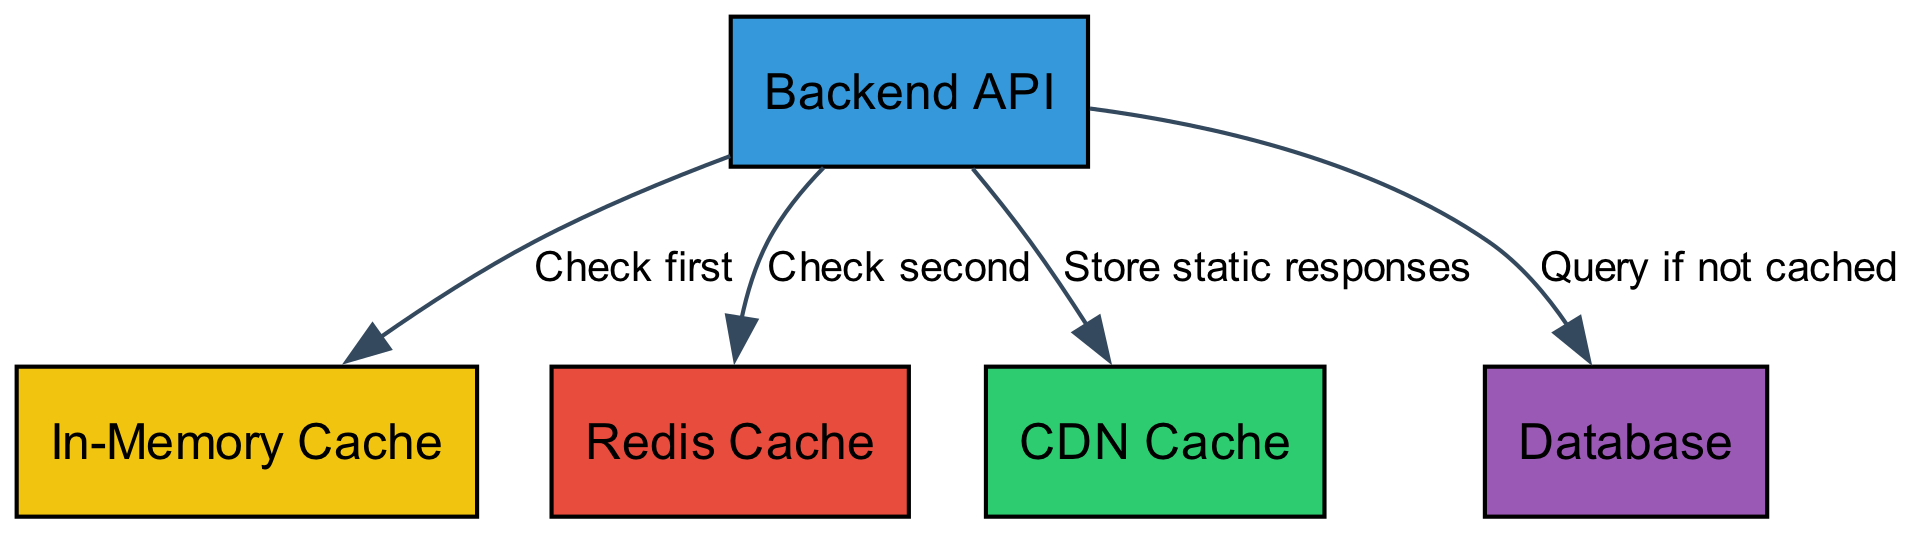What are the different caching layers shown in the diagram? The diagram includes five nodes: Backend API, In-Memory Cache, Redis Cache, CDN Cache, and Database. These represent the various layers of caching.
Answer: Backend API, In-Memory Cache, Redis Cache, CDN Cache, Database How many edges are there in the diagram? The total number of edges is determined by counting the connections between the nodes shown in the diagram: there are four edges connecting the API to the other layers.
Answer: 4 What does the API check first according to the diagram? The first layer the API checks is the In-Memory Cache. This is explicitly labeled on the edge leading from API to In-Memory Cache.
Answer: In-Memory Cache What type of cache is used to store static responses? The CDN Cache is specifically mentioned as the layer used to store static responses in the diagram.
Answer: CDN Cache If data is not found in the In-Memory Cache, where does the API check next? After checking the In-Memory Cache, the API proceeds to check the Redis Cache, as indicated in the connection labeled "Check second."
Answer: Redis Cache What action does the API take if data is not cached? If the data is not found in any cache, the API queries the Database, according to the edge labeled "Query if not cached."
Answer: Database Which caching layer has the API interact with the most edges? The Backend API has edges connecting it directly to In-Memory Cache, Redis Cache, and Database, making it the most connected layer in terms of direct interactions.
Answer: Backend API Which edge shows the action of storing data? The edge labeled "Store static responses" indicates the action of the API storing data specifically in the CDN Cache.
Answer: Store static responses What color represents the Redis Cache in the diagram? The color for the Redis Cache is indicated in the diagram as red. This is visually distinct among the other nodes.
Answer: Red 